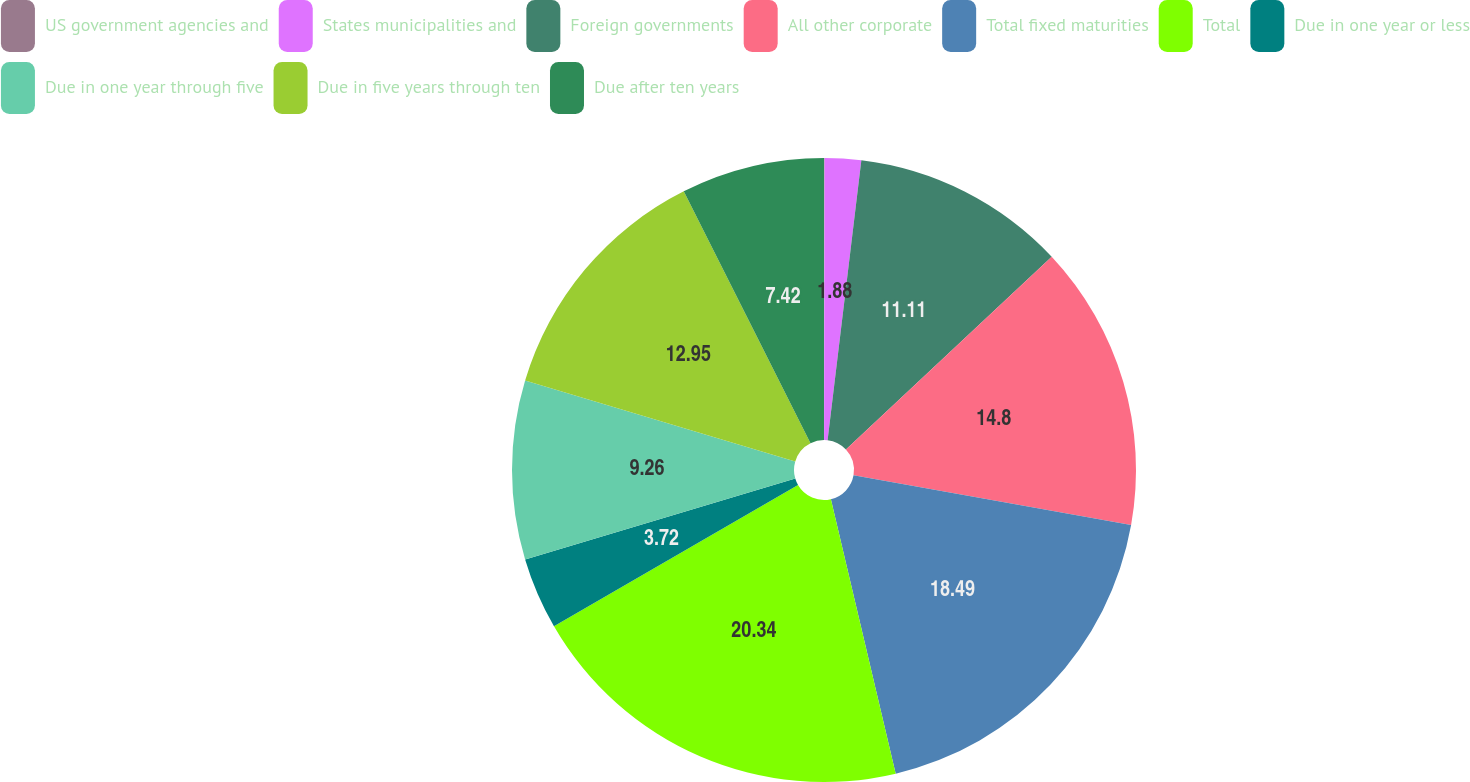Convert chart to OTSL. <chart><loc_0><loc_0><loc_500><loc_500><pie_chart><fcel>US government agencies and<fcel>States municipalities and<fcel>Foreign governments<fcel>All other corporate<fcel>Total fixed maturities<fcel>Total<fcel>Due in one year or less<fcel>Due in one year through five<fcel>Due in five years through ten<fcel>Due after ten years<nl><fcel>0.03%<fcel>1.88%<fcel>11.11%<fcel>14.8%<fcel>18.49%<fcel>20.34%<fcel>3.72%<fcel>9.26%<fcel>12.95%<fcel>7.42%<nl></chart> 